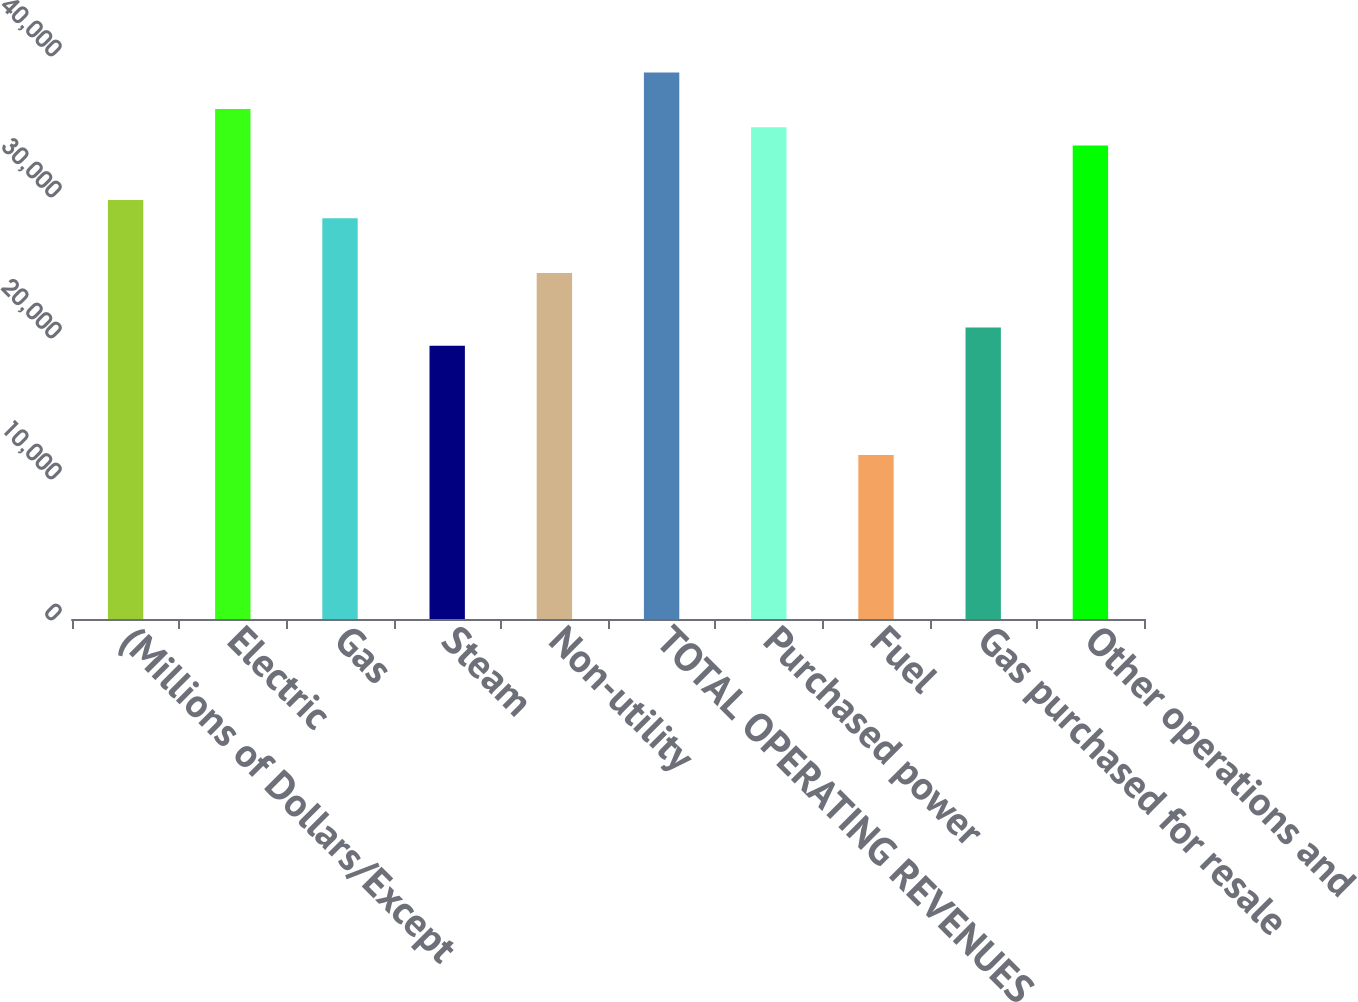Convert chart to OTSL. <chart><loc_0><loc_0><loc_500><loc_500><bar_chart><fcel>(Millions of Dollars/Except<fcel>Electric<fcel>Gas<fcel>Steam<fcel>Non-utility<fcel>TOTAL OPERATING REVENUES<fcel>Purchased power<fcel>Fuel<fcel>Gas purchased for resale<fcel>Other operations and<nl><fcel>29712.4<fcel>36171.4<fcel>28420.6<fcel>19378<fcel>24545.2<fcel>38755<fcel>34879.6<fcel>11627.2<fcel>20669.8<fcel>33587.8<nl></chart> 